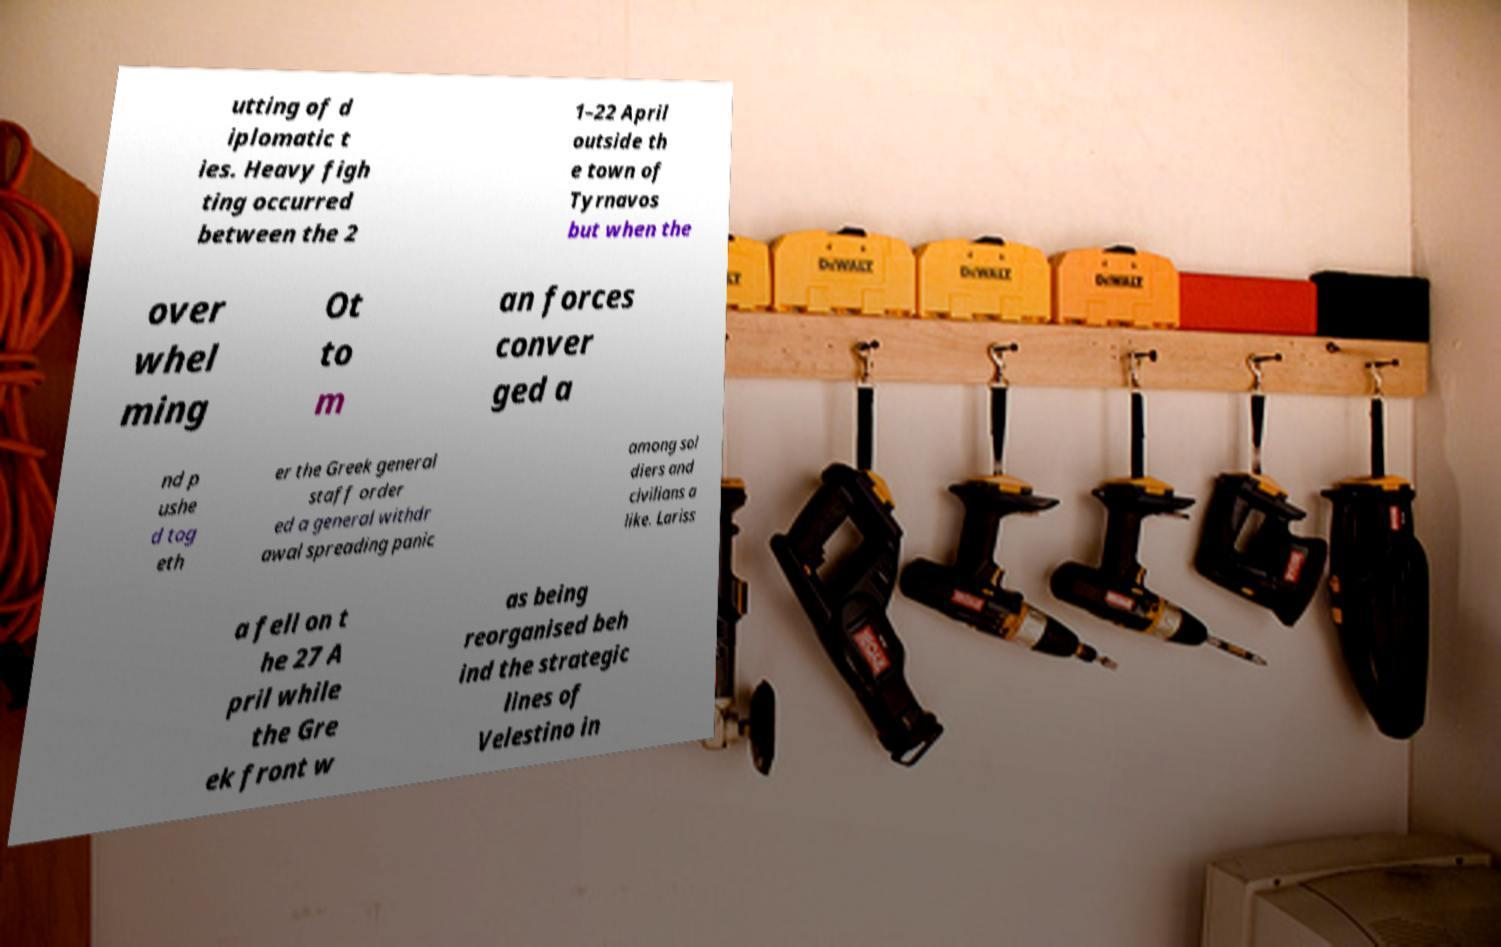Can you accurately transcribe the text from the provided image for me? utting of d iplomatic t ies. Heavy figh ting occurred between the 2 1–22 April outside th e town of Tyrnavos but when the over whel ming Ot to m an forces conver ged a nd p ushe d tog eth er the Greek general staff order ed a general withdr awal spreading panic among sol diers and civilians a like. Lariss a fell on t he 27 A pril while the Gre ek front w as being reorganised beh ind the strategic lines of Velestino in 